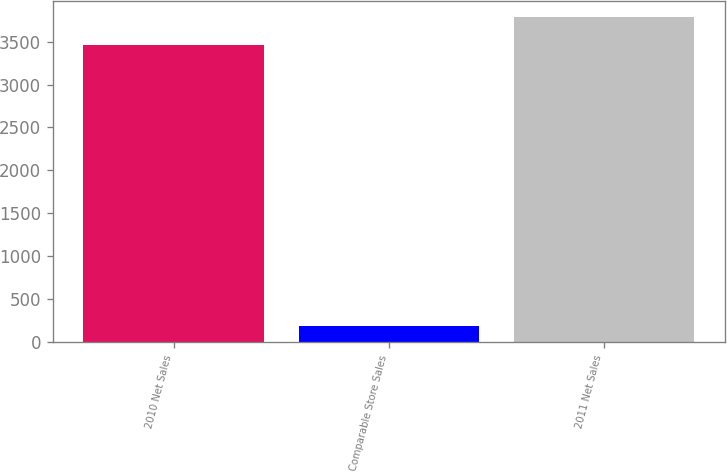Convert chart to OTSL. <chart><loc_0><loc_0><loc_500><loc_500><bar_chart><fcel>2010 Net Sales<fcel>Comparable Store Sales<fcel>2011 Net Sales<nl><fcel>3456<fcel>189<fcel>3788.6<nl></chart> 